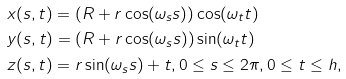<formula> <loc_0><loc_0><loc_500><loc_500>& x ( s , t ) = ( R + r \cos ( \omega _ { s } s ) ) \cos ( \omega _ { t } t ) \\ & y ( s , t ) = ( R + r \cos ( \omega _ { s } s ) ) \sin ( \omega _ { t } t ) \\ & z ( s , t ) = r \sin ( \omega _ { s } s ) + t , 0 \leq s \leq 2 \pi , 0 \leq t \leq h ,</formula> 